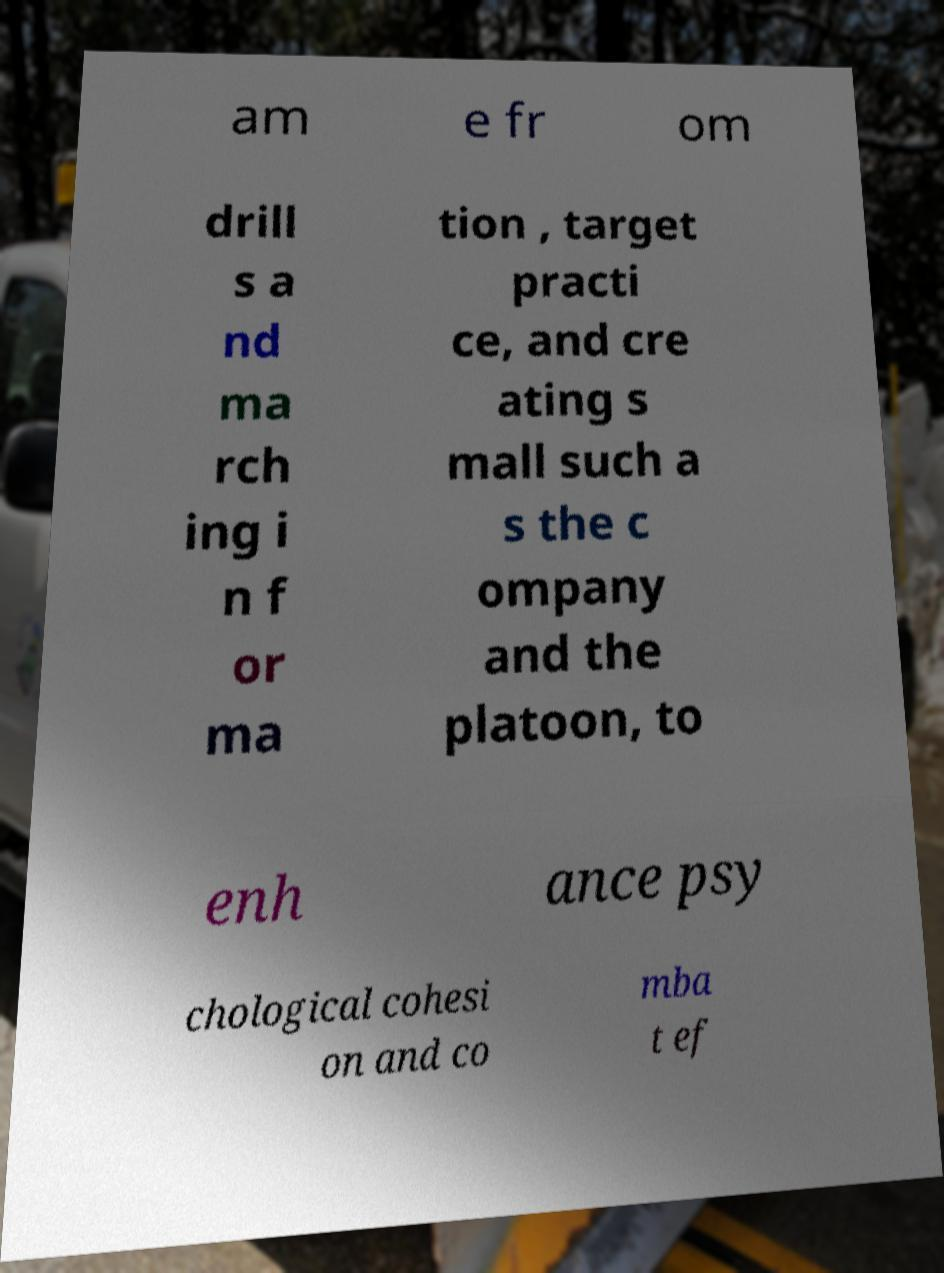There's text embedded in this image that I need extracted. Can you transcribe it verbatim? am e fr om drill s a nd ma rch ing i n f or ma tion , target practi ce, and cre ating s mall such a s the c ompany and the platoon, to enh ance psy chological cohesi on and co mba t ef 